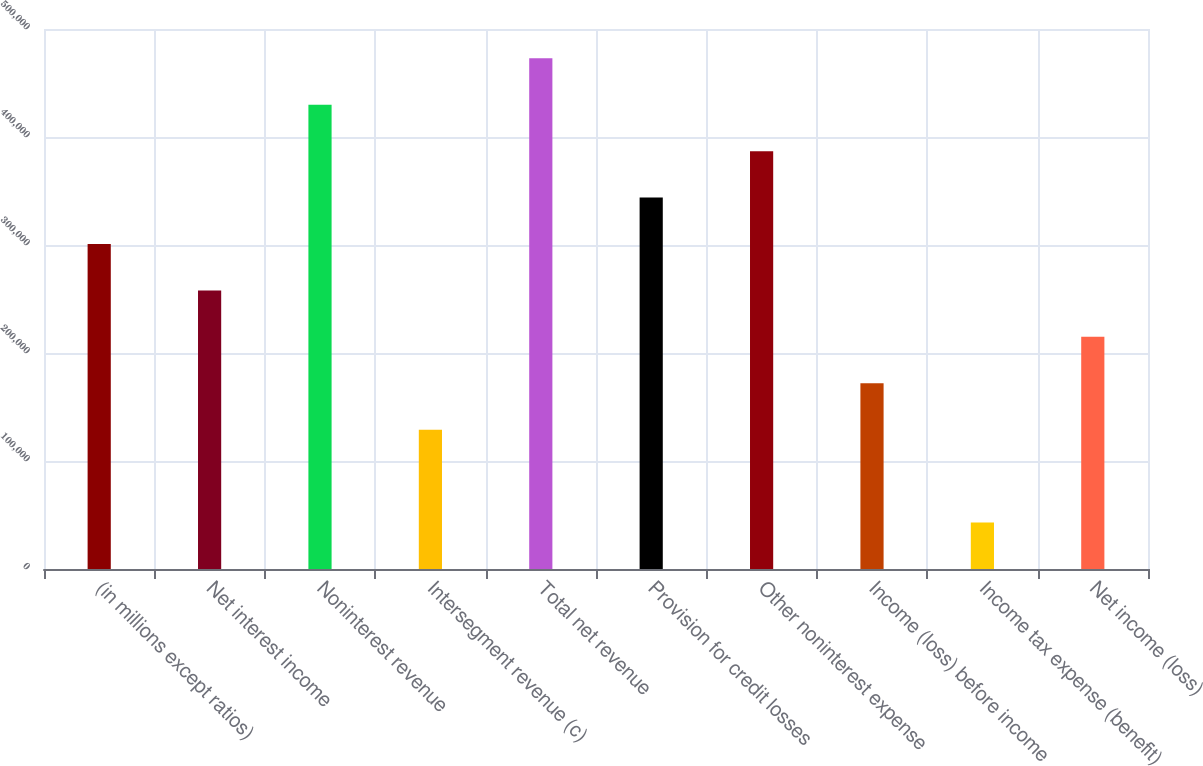Convert chart to OTSL. <chart><loc_0><loc_0><loc_500><loc_500><bar_chart><fcel>(in millions except ratios)<fcel>Net interest income<fcel>Noninterest revenue<fcel>Intersegment revenue (c)<fcel>Total net revenue<fcel>Provision for credit losses<fcel>Other noninterest expense<fcel>Income (loss) before income<fcel>Income tax expense (benefit)<fcel>Net income (loss)<nl><fcel>300907<fcel>257920<fcel>429866<fcel>128961<fcel>472852<fcel>343893<fcel>386880<fcel>171948<fcel>42988.4<fcel>214934<nl></chart> 